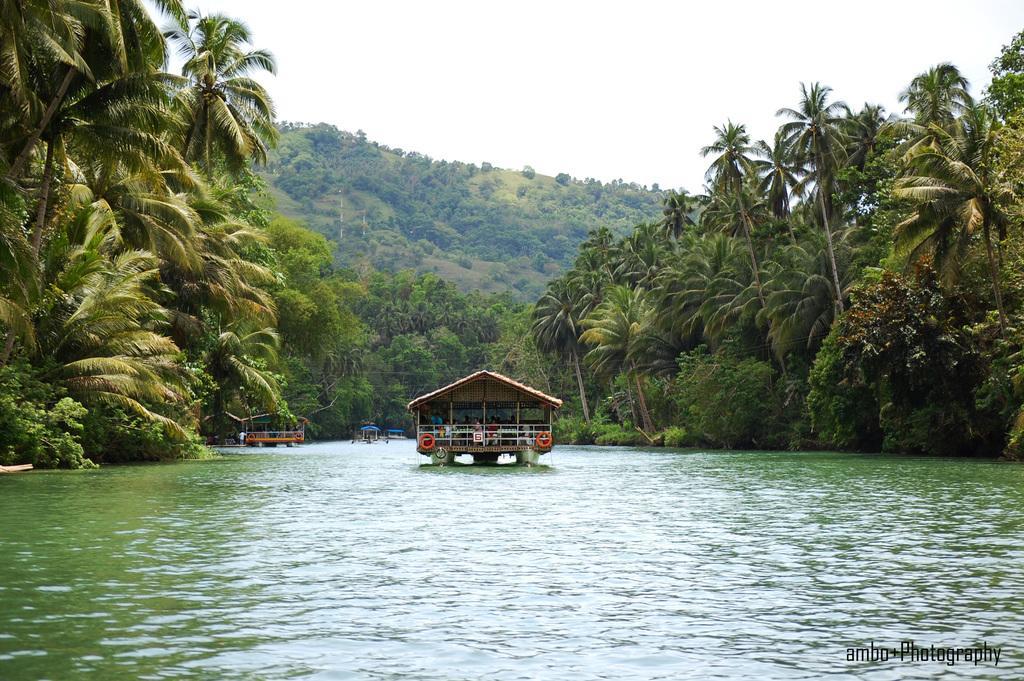Can you describe this image briefly? In this picture we can see boats which is in the shape of hut. On the boat we can see the group of persons standing near to the fencing. At the bottom there is a water. In the bottom right corner there is a watermark. In the background we can see mountain, trees, plants and grass. At the top there is a sky. 